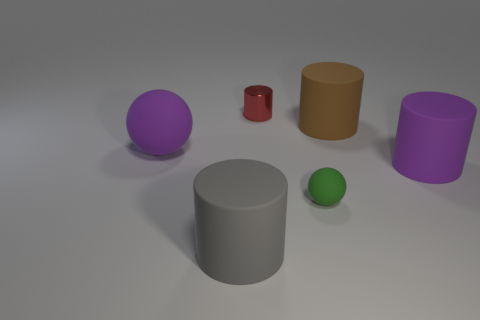There is a cylinder that is the same color as the large sphere; what material is it?
Your response must be concise. Rubber. What number of things are either big purple things or matte spheres that are on the left side of the small ball?
Give a very brief answer. 2. Do the brown cylinder and the tiny green thing have the same material?
Provide a short and direct response. Yes. What number of other objects are there of the same material as the gray cylinder?
Your response must be concise. 4. Is the number of brown rubber cylinders greater than the number of big red spheres?
Your response must be concise. Yes. There is a big rubber object in front of the small matte sphere; does it have the same shape as the small green object?
Your answer should be very brief. No. Are there fewer cyan rubber objects than brown things?
Offer a terse response. Yes. There is a red cylinder that is the same size as the green thing; what is its material?
Your answer should be very brief. Metal. There is a small cylinder; is it the same color as the tiny matte object in front of the brown rubber thing?
Give a very brief answer. No. Is the number of brown cylinders that are in front of the purple rubber ball less than the number of big gray shiny objects?
Your answer should be very brief. No. 